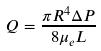Convert formula to latex. <formula><loc_0><loc_0><loc_500><loc_500>Q = \frac { \pi R ^ { 4 } \Delta P } { 8 \mu _ { e } L }</formula> 